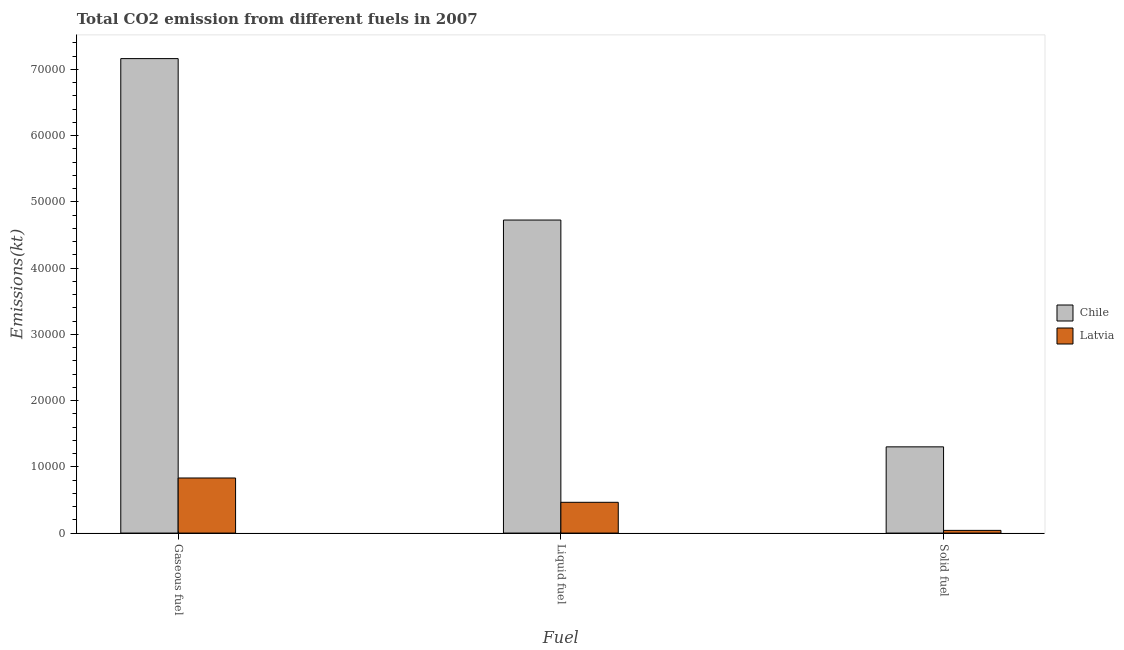How many different coloured bars are there?
Provide a short and direct response. 2. What is the label of the 1st group of bars from the left?
Offer a terse response. Gaseous fuel. What is the amount of co2 emissions from solid fuel in Chile?
Provide a succinct answer. 1.30e+04. Across all countries, what is the maximum amount of co2 emissions from liquid fuel?
Provide a short and direct response. 4.73e+04. Across all countries, what is the minimum amount of co2 emissions from solid fuel?
Keep it short and to the point. 407.04. In which country was the amount of co2 emissions from liquid fuel minimum?
Your answer should be compact. Latvia. What is the total amount of co2 emissions from solid fuel in the graph?
Provide a short and direct response. 1.34e+04. What is the difference between the amount of co2 emissions from gaseous fuel in Latvia and that in Chile?
Offer a very short reply. -6.33e+04. What is the difference between the amount of co2 emissions from liquid fuel in Chile and the amount of co2 emissions from solid fuel in Latvia?
Keep it short and to the point. 4.69e+04. What is the average amount of co2 emissions from solid fuel per country?
Your answer should be very brief. 6712.44. What is the difference between the amount of co2 emissions from liquid fuel and amount of co2 emissions from gaseous fuel in Latvia?
Give a very brief answer. -3670.67. In how many countries, is the amount of co2 emissions from liquid fuel greater than 12000 kt?
Provide a short and direct response. 1. What is the ratio of the amount of co2 emissions from gaseous fuel in Chile to that in Latvia?
Make the answer very short. 8.61. Is the amount of co2 emissions from gaseous fuel in Latvia less than that in Chile?
Your answer should be very brief. Yes. Is the difference between the amount of co2 emissions from liquid fuel in Chile and Latvia greater than the difference between the amount of co2 emissions from gaseous fuel in Chile and Latvia?
Your response must be concise. No. What is the difference between the highest and the second highest amount of co2 emissions from solid fuel?
Your answer should be compact. 1.26e+04. What is the difference between the highest and the lowest amount of co2 emissions from solid fuel?
Your response must be concise. 1.26e+04. Is the sum of the amount of co2 emissions from solid fuel in Chile and Latvia greater than the maximum amount of co2 emissions from gaseous fuel across all countries?
Provide a succinct answer. No. What does the 2nd bar from the left in Liquid fuel represents?
Offer a very short reply. Latvia. Are all the bars in the graph horizontal?
Your answer should be compact. No. What is the difference between two consecutive major ticks on the Y-axis?
Offer a terse response. 10000. Are the values on the major ticks of Y-axis written in scientific E-notation?
Offer a terse response. No. Does the graph contain any zero values?
Keep it short and to the point. No. What is the title of the graph?
Offer a very short reply. Total CO2 emission from different fuels in 2007. What is the label or title of the X-axis?
Offer a very short reply. Fuel. What is the label or title of the Y-axis?
Your answer should be very brief. Emissions(kt). What is the Emissions(kt) of Chile in Gaseous fuel?
Your answer should be compact. 7.16e+04. What is the Emissions(kt) of Latvia in Gaseous fuel?
Offer a very short reply. 8316.76. What is the Emissions(kt) in Chile in Liquid fuel?
Give a very brief answer. 4.73e+04. What is the Emissions(kt) in Latvia in Liquid fuel?
Your answer should be very brief. 4646.09. What is the Emissions(kt) of Chile in Solid fuel?
Provide a short and direct response. 1.30e+04. What is the Emissions(kt) of Latvia in Solid fuel?
Offer a terse response. 407.04. Across all Fuel, what is the maximum Emissions(kt) of Chile?
Your answer should be compact. 7.16e+04. Across all Fuel, what is the maximum Emissions(kt) of Latvia?
Make the answer very short. 8316.76. Across all Fuel, what is the minimum Emissions(kt) in Chile?
Your answer should be very brief. 1.30e+04. Across all Fuel, what is the minimum Emissions(kt) in Latvia?
Give a very brief answer. 407.04. What is the total Emissions(kt) of Chile in the graph?
Offer a very short reply. 1.32e+05. What is the total Emissions(kt) of Latvia in the graph?
Give a very brief answer. 1.34e+04. What is the difference between the Emissions(kt) in Chile in Gaseous fuel and that in Liquid fuel?
Offer a terse response. 2.44e+04. What is the difference between the Emissions(kt) of Latvia in Gaseous fuel and that in Liquid fuel?
Offer a terse response. 3670.67. What is the difference between the Emissions(kt) of Chile in Gaseous fuel and that in Solid fuel?
Your answer should be compact. 5.86e+04. What is the difference between the Emissions(kt) in Latvia in Gaseous fuel and that in Solid fuel?
Offer a very short reply. 7909.72. What is the difference between the Emissions(kt) of Chile in Liquid fuel and that in Solid fuel?
Your answer should be compact. 3.42e+04. What is the difference between the Emissions(kt) of Latvia in Liquid fuel and that in Solid fuel?
Give a very brief answer. 4239.05. What is the difference between the Emissions(kt) in Chile in Gaseous fuel and the Emissions(kt) in Latvia in Liquid fuel?
Make the answer very short. 6.70e+04. What is the difference between the Emissions(kt) of Chile in Gaseous fuel and the Emissions(kt) of Latvia in Solid fuel?
Keep it short and to the point. 7.12e+04. What is the difference between the Emissions(kt) of Chile in Liquid fuel and the Emissions(kt) of Latvia in Solid fuel?
Give a very brief answer. 4.69e+04. What is the average Emissions(kt) of Chile per Fuel?
Keep it short and to the point. 4.40e+04. What is the average Emissions(kt) in Latvia per Fuel?
Offer a terse response. 4456.63. What is the difference between the Emissions(kt) in Chile and Emissions(kt) in Latvia in Gaseous fuel?
Provide a short and direct response. 6.33e+04. What is the difference between the Emissions(kt) of Chile and Emissions(kt) of Latvia in Liquid fuel?
Your answer should be compact. 4.26e+04. What is the difference between the Emissions(kt) in Chile and Emissions(kt) in Latvia in Solid fuel?
Offer a very short reply. 1.26e+04. What is the ratio of the Emissions(kt) of Chile in Gaseous fuel to that in Liquid fuel?
Offer a very short reply. 1.52. What is the ratio of the Emissions(kt) in Latvia in Gaseous fuel to that in Liquid fuel?
Make the answer very short. 1.79. What is the ratio of the Emissions(kt) in Chile in Gaseous fuel to that in Solid fuel?
Your answer should be compact. 5.5. What is the ratio of the Emissions(kt) of Latvia in Gaseous fuel to that in Solid fuel?
Your answer should be compact. 20.43. What is the ratio of the Emissions(kt) of Chile in Liquid fuel to that in Solid fuel?
Make the answer very short. 3.63. What is the ratio of the Emissions(kt) of Latvia in Liquid fuel to that in Solid fuel?
Offer a very short reply. 11.41. What is the difference between the highest and the second highest Emissions(kt) in Chile?
Offer a very short reply. 2.44e+04. What is the difference between the highest and the second highest Emissions(kt) of Latvia?
Your answer should be very brief. 3670.67. What is the difference between the highest and the lowest Emissions(kt) of Chile?
Provide a succinct answer. 5.86e+04. What is the difference between the highest and the lowest Emissions(kt) of Latvia?
Ensure brevity in your answer.  7909.72. 